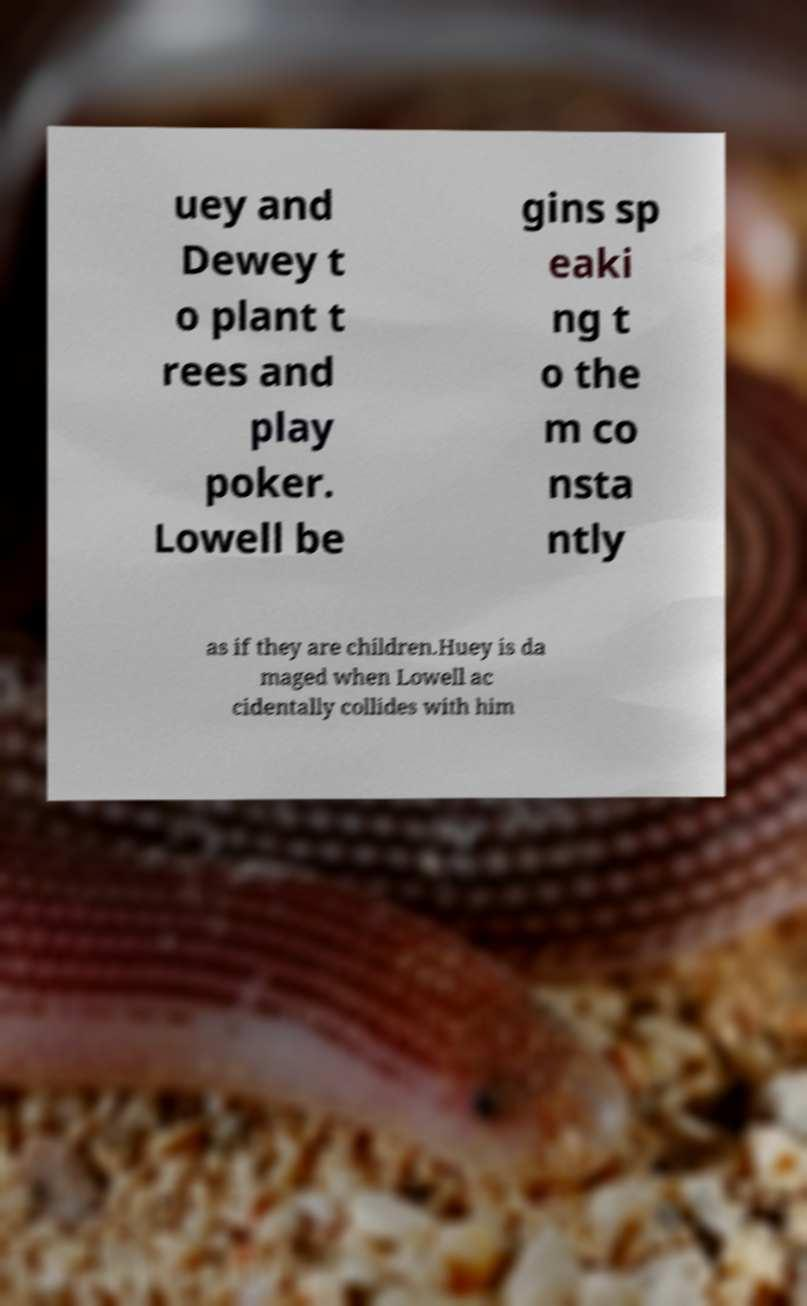What messages or text are displayed in this image? I need them in a readable, typed format. uey and Dewey t o plant t rees and play poker. Lowell be gins sp eaki ng t o the m co nsta ntly as if they are children.Huey is da maged when Lowell ac cidentally collides with him 